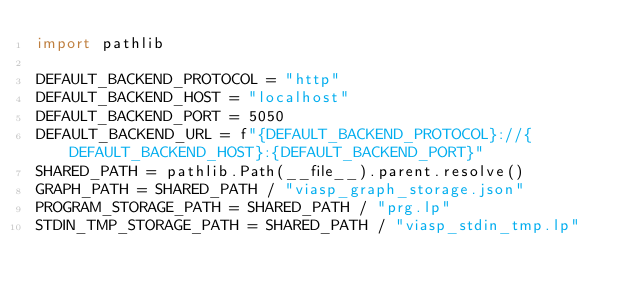Convert code to text. <code><loc_0><loc_0><loc_500><loc_500><_Python_>import pathlib

DEFAULT_BACKEND_PROTOCOL = "http"
DEFAULT_BACKEND_HOST = "localhost"
DEFAULT_BACKEND_PORT = 5050
DEFAULT_BACKEND_URL = f"{DEFAULT_BACKEND_PROTOCOL}://{DEFAULT_BACKEND_HOST}:{DEFAULT_BACKEND_PORT}"
SHARED_PATH = pathlib.Path(__file__).parent.resolve()
GRAPH_PATH = SHARED_PATH / "viasp_graph_storage.json"
PROGRAM_STORAGE_PATH = SHARED_PATH / "prg.lp"
STDIN_TMP_STORAGE_PATH = SHARED_PATH / "viasp_stdin_tmp.lp"
</code> 